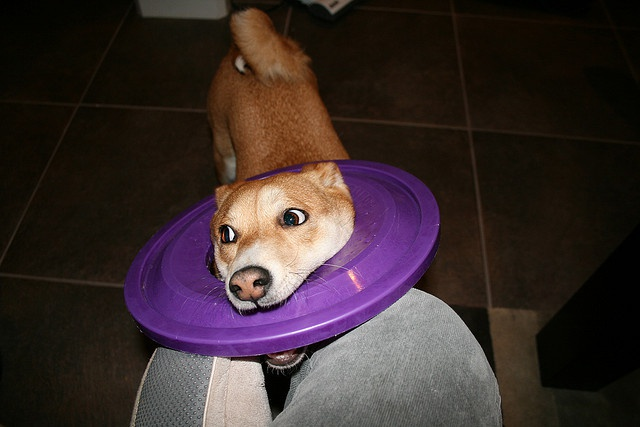Describe the objects in this image and their specific colors. I can see dog in black, maroon, and brown tones, frisbee in black, purple, and navy tones, and people in black, darkgray, gray, and lightgray tones in this image. 